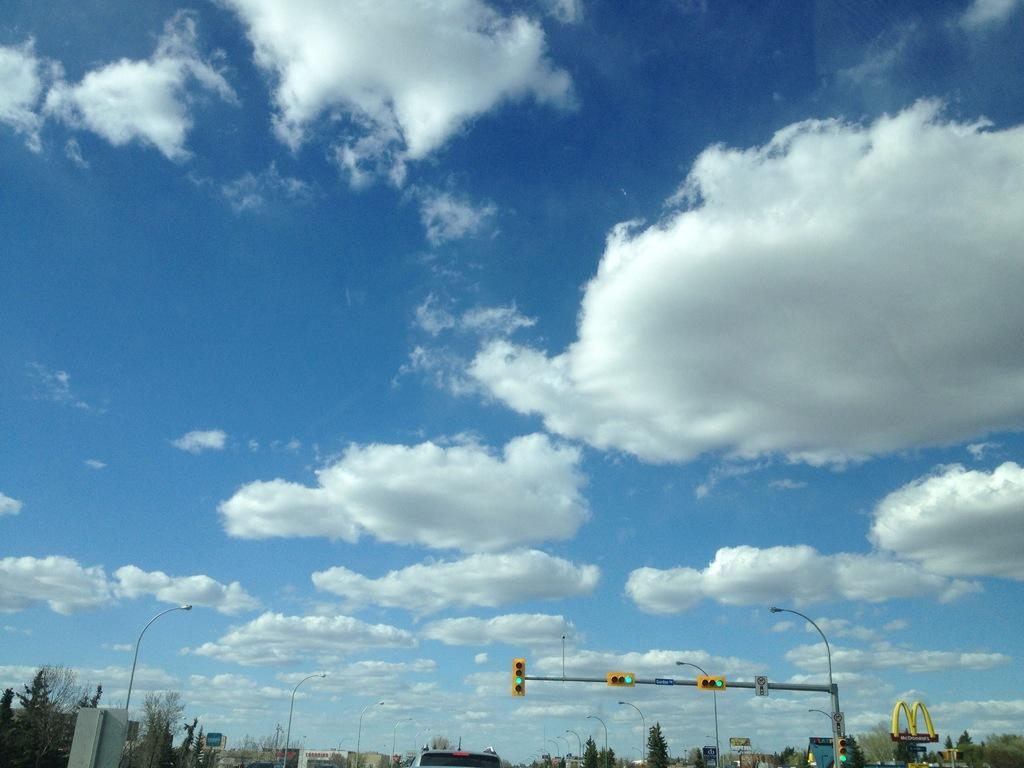What type of natural elements can be seen in the image? There are trees in the image. What man-made structures are present in the image? There are light poles and boards in the image. What function do the light poles serve in the image? Traffic signals are attached to the light poles in the image. What is the color of the sky in the image? The sky is blue and white in color. Can you see a hen playing chess in the image? No, there is no hen or chess game present in the image. Is there a bath visible in the image? No, there is no bath present in the image. 